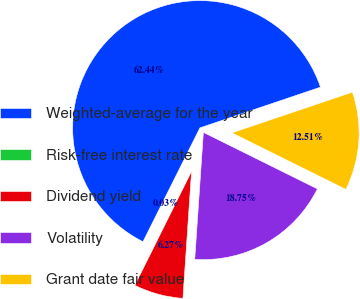<chart> <loc_0><loc_0><loc_500><loc_500><pie_chart><fcel>Weighted-average for the year<fcel>Risk-free interest rate<fcel>Dividend yield<fcel>Volatility<fcel>Grant date fair value<nl><fcel>62.43%<fcel>0.03%<fcel>6.27%<fcel>18.75%<fcel>12.51%<nl></chart> 